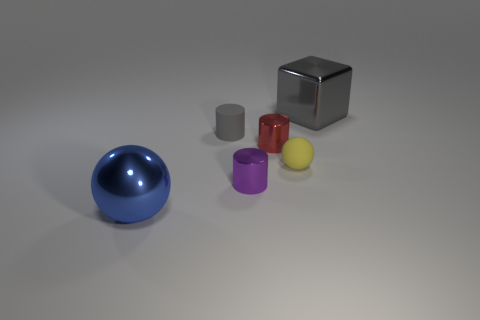Add 1 blue rubber objects. How many objects exist? 7 Subtract 0 brown cylinders. How many objects are left? 6 Subtract all blocks. How many objects are left? 5 Subtract all large green matte cubes. Subtract all small gray matte cylinders. How many objects are left? 5 Add 3 red shiny cylinders. How many red shiny cylinders are left? 4 Add 3 small matte cylinders. How many small matte cylinders exist? 4 